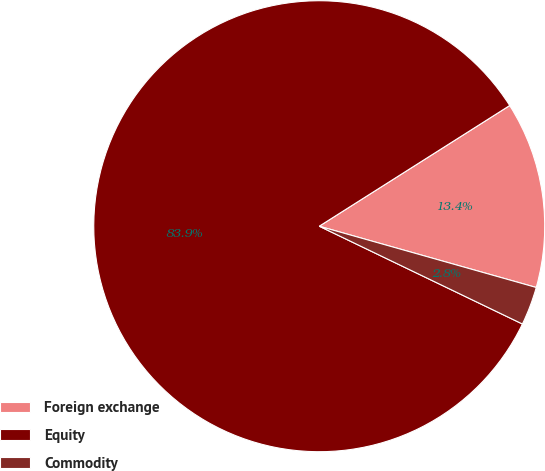Convert chart. <chart><loc_0><loc_0><loc_500><loc_500><pie_chart><fcel>Foreign exchange<fcel>Equity<fcel>Commodity<nl><fcel>13.37%<fcel>83.87%<fcel>2.76%<nl></chart> 